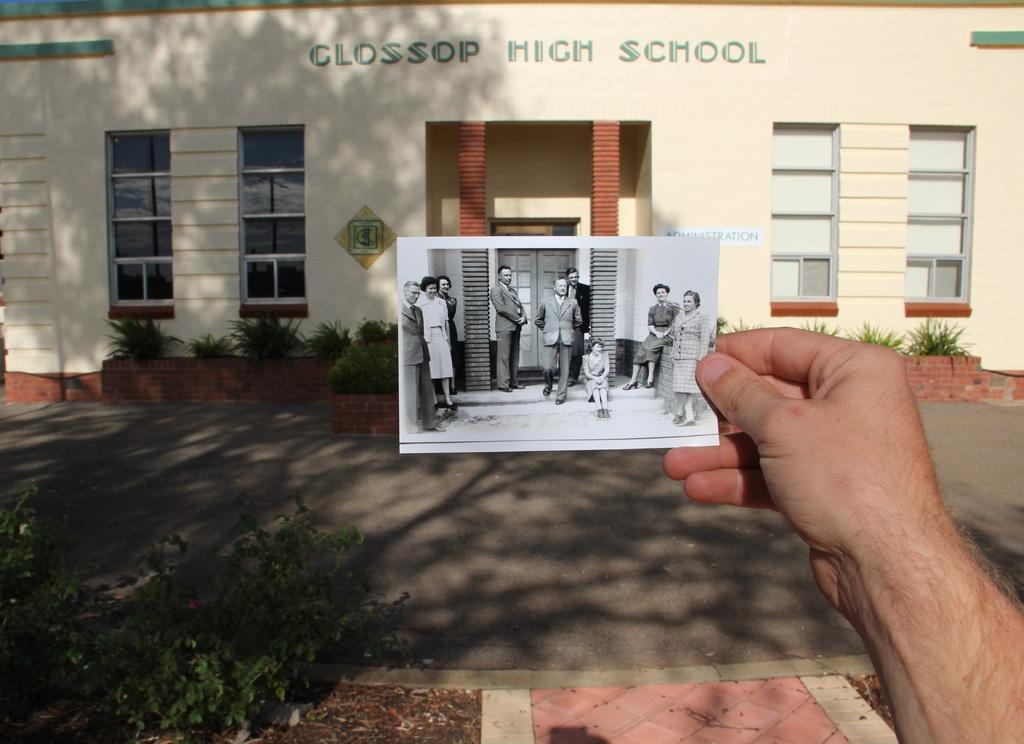What is the person in the image holding? The person is holding a photograph in the image. What can be seen to the left of the person? There is a plant to the left of the person. What is visible in the background of the image? There is a building in the background of the image. What architectural feature is present in the building? There is a window in the building. What is at the bottom of the image? There is a road at the bottom of the image. Where is the cave located in the image? There is no cave present in the image. How does the person in the image express pain? The image does not show any indication of the person experiencing pain. 